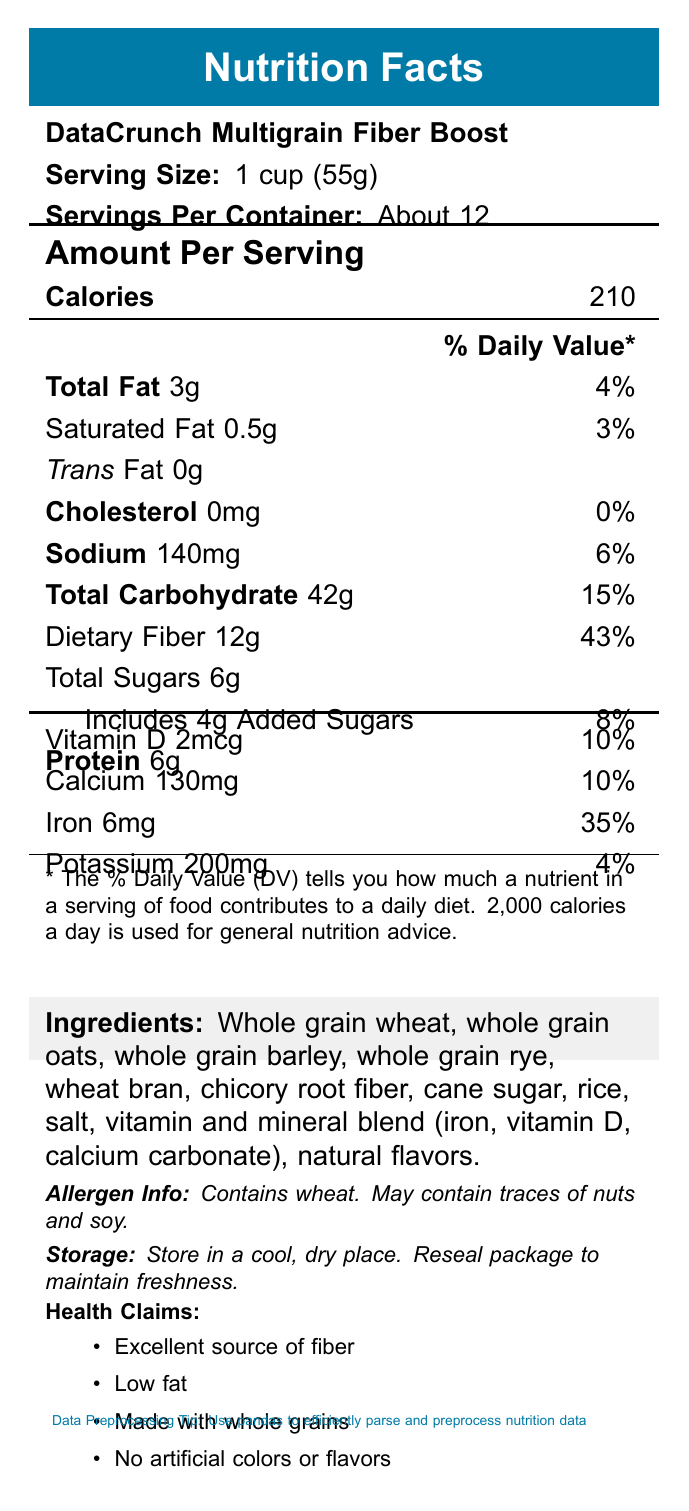what is the serving size for DataCrunch Multigrain Fiber Boost? The document lists the serving size as "1 cup (55g)" in the section next to the product name.
Answer: 1 cup (55g) how many calories are in one serving? The document specifies that there are 210 calories per serving in the "Amount Per Serving" section.
Answer: 210 what are the health claims associated with this cereal? The health claims listed are "Excellent source of fiber," "Low fat," "Made with whole grains," and "No artificial colors or flavors."
Answer: Excellent source of fiber, Low fat, Made with whole grains, No artificial colors or flavors what is the total carbohydrate content per serving? A. 15g B. 42g C. 21g D. 36g The document specifies that there are 42g of total carbohydrates per serving.
Answer: B. 42g what is the percentage daily value of iron in one serving? A. 6% B. 10% C. 35% D. 50% The "Iron" line shows that one serving has 6mg of iron, which is 35% of the daily value.
Answer: C. 35% does this cereal contain any cholesterol? The document states that the cholesterol amount is 0mg, and the daily value is 0%.
Answer: No what is the main idea of the document? The entire document is focused on giving a comprehensive overview of the nutritional value, ingredients, and other relevant information about the DataCrunch Multigrain Fiber Boost cereal.
Answer: The document provides detailed nutritional information for DataCrunch Multigrain Fiber Boost, a high-fiber breakfast cereal. It includes serving size, calorie count, nutrient content, ingredients, allergen information, health claims, and storage instructions. how many servings are there per container? The document mentions that there are "About 12" servings per container next to the serving size information.
Answer: About 12 does this product contain artificial colors or flavors? One of the health claims is "No artificial colors or flavors."
Answer: No which grains are included in the ingredients? The ingredients list includes whole grain wheat, whole grain oats, whole grain barley, and whole grain rye.
Answer: Whole grain wheat, Whole grain oats, Whole grain barley, Whole grain rye what are some machine learning tips mentioned in the document? The document does not contain visible information related to machine learning tips.
Answer: Cannot be determined 